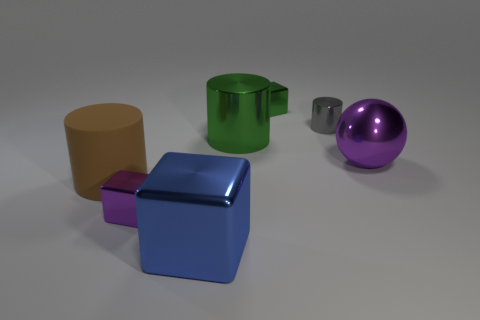Subtract all small metal cubes. How many cubes are left? 1 Add 1 small green rubber balls. How many objects exist? 8 Subtract all balls. How many objects are left? 6 Subtract 2 cubes. How many cubes are left? 1 Add 6 small purple metal things. How many small purple metal things are left? 7 Add 7 brown things. How many brown things exist? 8 Subtract 0 gray spheres. How many objects are left? 7 Subtract all cyan cubes. Subtract all red cylinders. How many cubes are left? 3 Subtract all large metal things. Subtract all tiny green blocks. How many objects are left? 3 